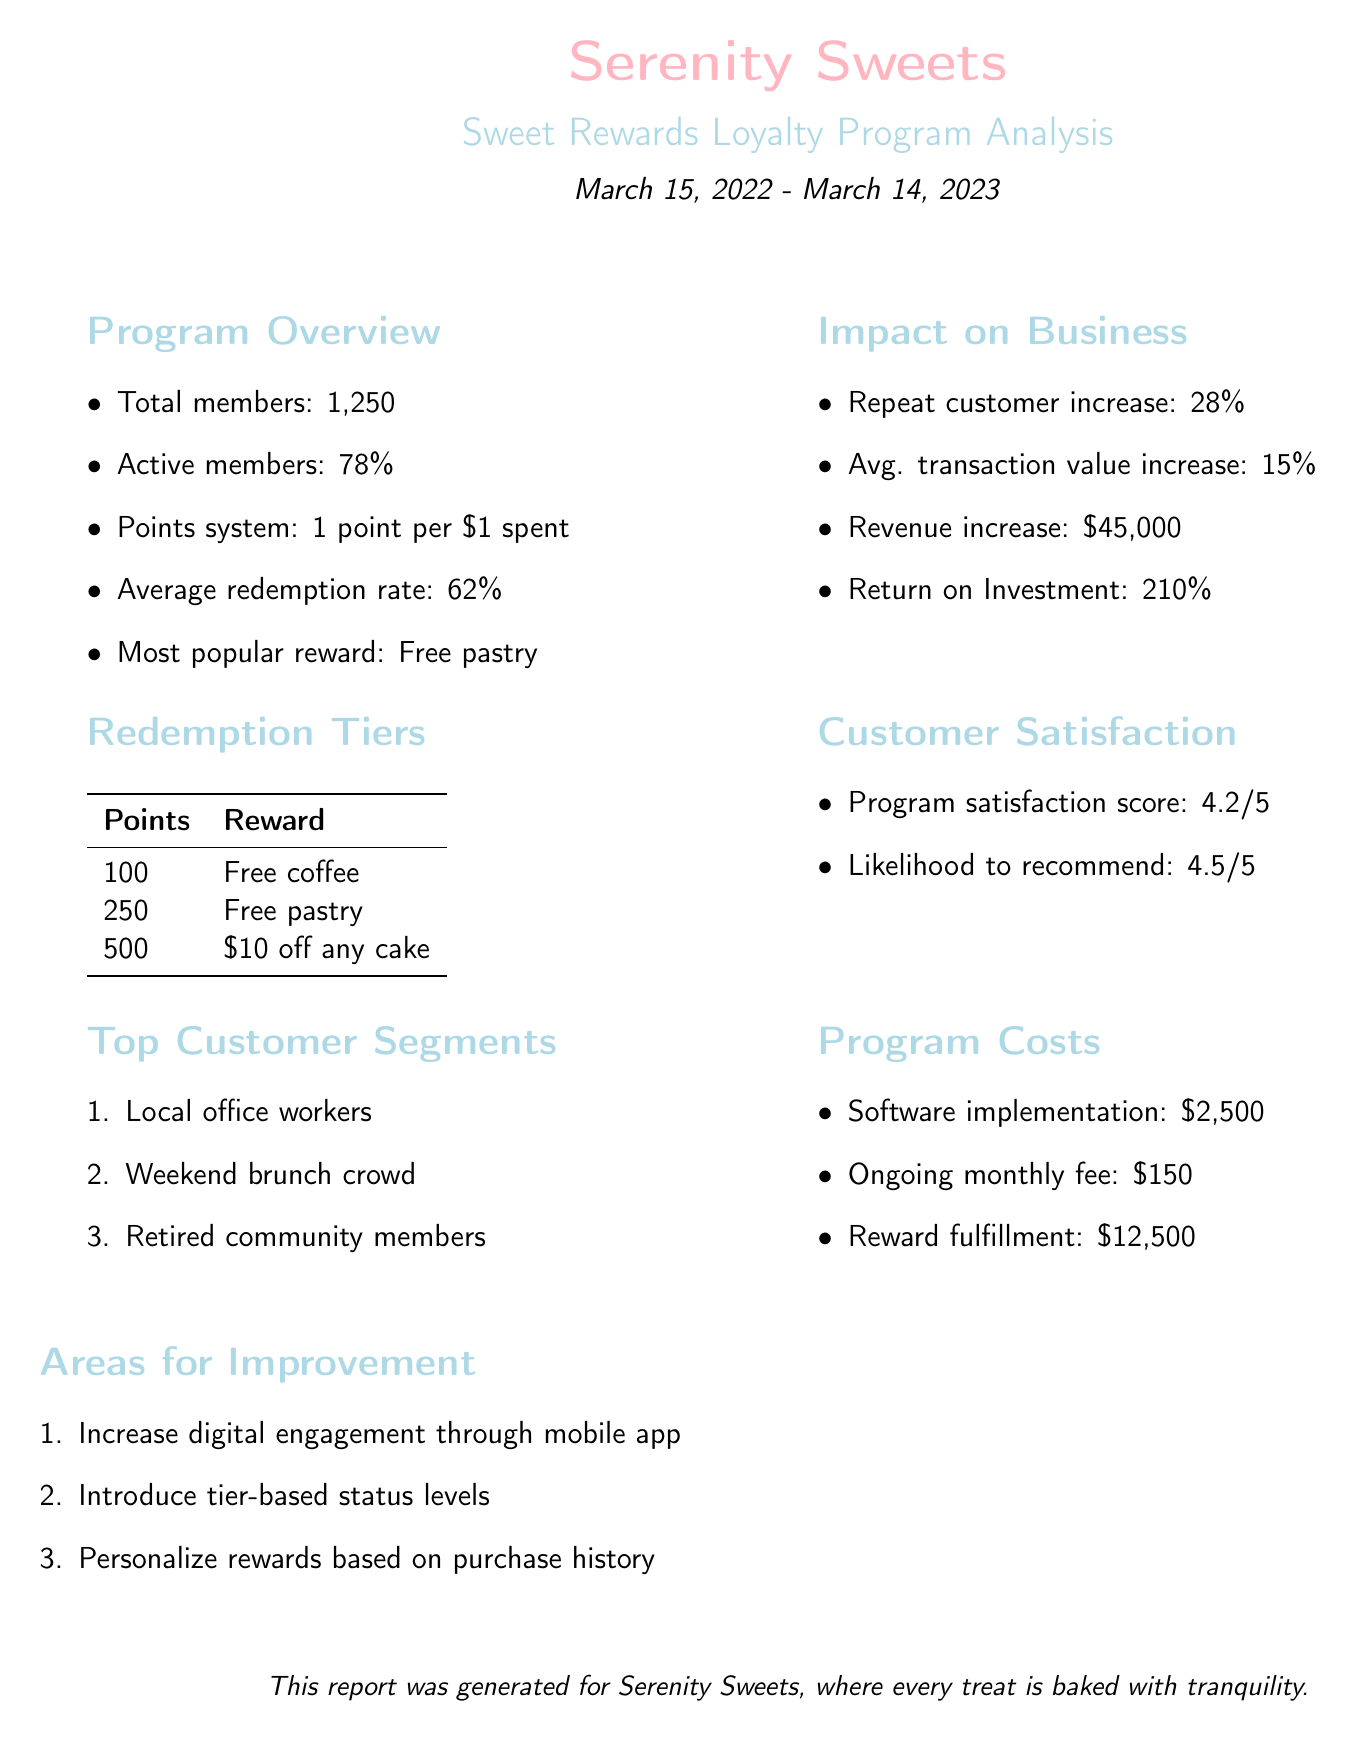What is the name of the loyalty program? The name of the loyalty program is mentioned in the document as "Sweet Rewards."
Answer: Sweet Rewards What is the average redemption rate? The average redemption rate is explicitly stated in the document as 62%.
Answer: 62% How many total program members are there? Total program members are indicated in the document as 1,250.
Answer: 1,250 What is the most popular reward? The most popular reward listed in the document is "Free pastry."
Answer: Free pastry What percentage of customers are active members? The document states that the active members percentage is 78%.
Answer: 78% What was the increase in repeat customers? The repeat customer increase mentioned in the document is 28%.
Answer: 28% What was the return on investment? The document reflects that the return on investment is 210%.
Answer: 210% What was the revenue increase attributed to the program? The document specifies that the revenue increase attributed to the program is $45,000.
Answer: $45,000 What are the areas for improvement? The document lists areas for improvement, including increasing digital engagement through a mobile app, introducing tier-based status levels, and personalizing rewards based on purchase history.
Answer: Increase digital engagement, introduce tier-based status levels, personalize rewards 